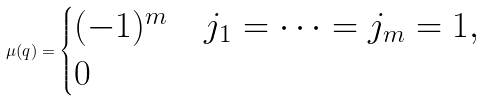<formula> <loc_0><loc_0><loc_500><loc_500>\mu ( q ) = \begin{cases} ( - 1 ) ^ { m } & j _ { 1 } = \cdots = j _ { m } = 1 , \\ 0 & \end{cases}</formula> 